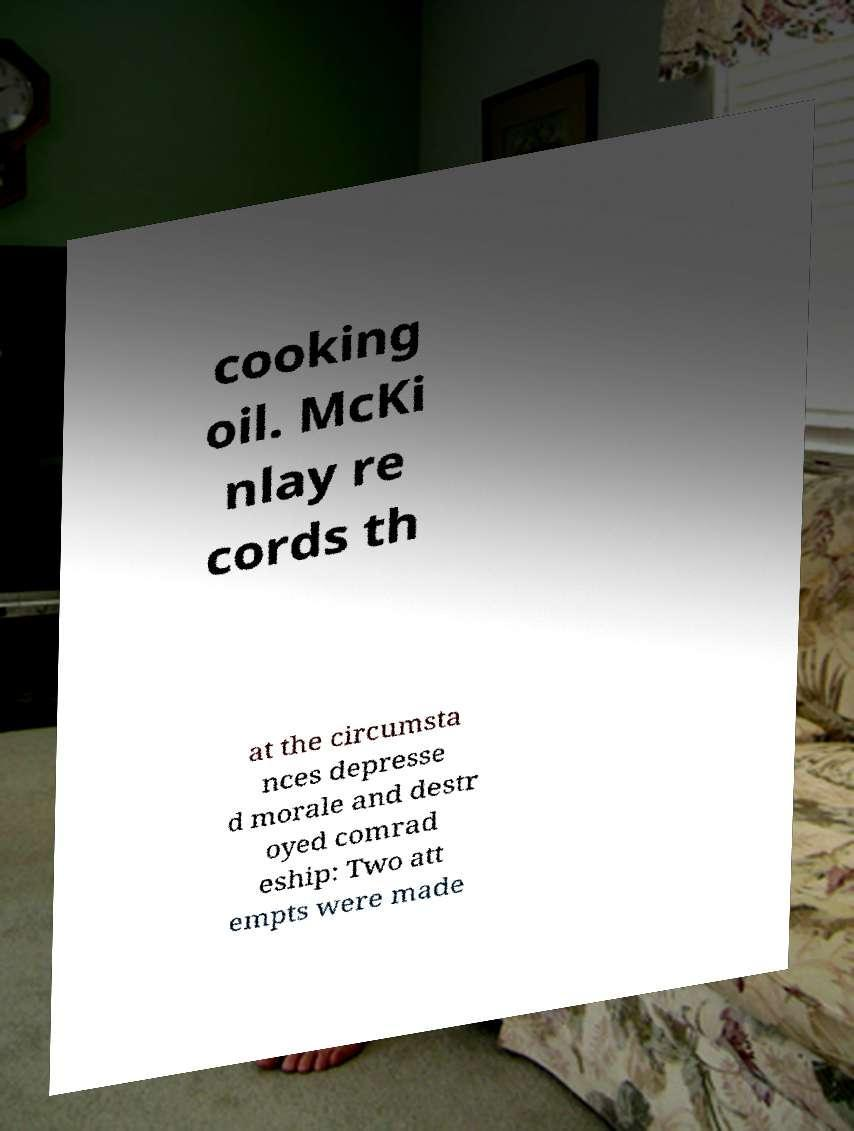There's text embedded in this image that I need extracted. Can you transcribe it verbatim? cooking oil. McKi nlay re cords th at the circumsta nces depresse d morale and destr oyed comrad eship: Two att empts were made 